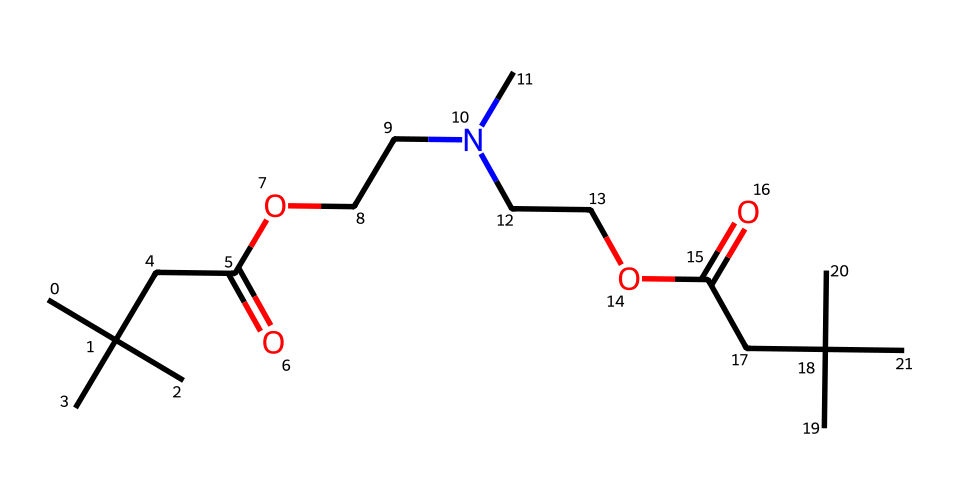how many carbon atoms are in this molecule? Count the number of carbon (C) symbols in the SMILES representation. The molecule contains 14 carbon symbols, indicating there are 14 carbon atoms.
Answer: 14 what functional groups are present in this molecule? By analyzing the structure, we see the presence of a carboxylic acid group (CC(=O)O) and an amine group (N(C)CC). Therefore, we identify both functional groups as present in the molecule.
Answer: carboxylic acid and amine what type of reaction could this molecule undergo? This molecule can undergo esterification due to its carboxylic acid and alcohol components. It can also participate in condensation reactions due to the presence of amines and alcohols in its structure.
Answer: esterification or condensation how many oxygen atoms are in this molecule? The SMILES representation includes the oxygen symbols; counting them shows there are four oxygen symbols, indicating four oxygen atoms are present.
Answer: 4 what is the molecular weight of this compound? The molecular weight can be calculated by adding the weights of all the constituent atoms: carbon (C), hydrogen (H), nitrogen (N), and oxygen (O). After calculation, the total comes to about 274 g/mol.
Answer: 274 g/mol does this molecule have potential for being flexible in upholstery? The presence of long carbon chains and functional groups typically associated with flexibility in polyurethanes suggests that this molecule can offer flexibility in upholstery applications.
Answer: yes 